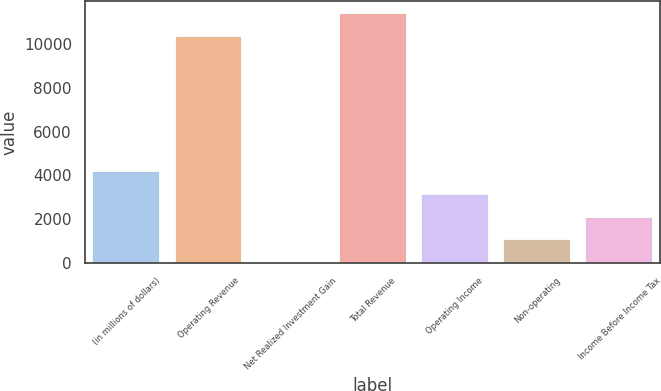<chart> <loc_0><loc_0><loc_500><loc_500><bar_chart><fcel>(in millions of dollars)<fcel>Operating Revenue<fcel>Net Realized Investment Gain<fcel>Total Revenue<fcel>Operating Income<fcel>Non-operating<fcel>Income Before Income Tax<nl><fcel>4145.6<fcel>10347<fcel>6.8<fcel>11381.7<fcel>3110.9<fcel>1041.5<fcel>2076.2<nl></chart> 